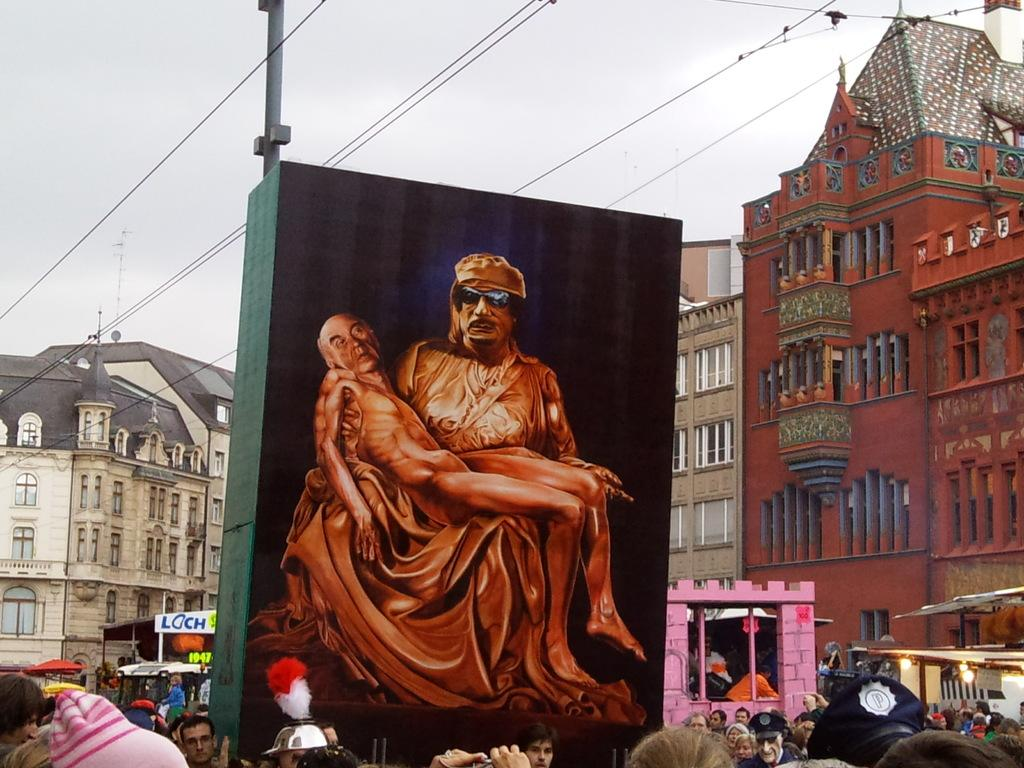How many people can be seen in the image? There are people in the image, but the exact number is not specified. What is depicted on the board in the image? There is a board with an image of two persons in the image. What type of structures are visible in the image? There are buildings with windows in the image. What can be seen illuminating the scene in the image? There are lights visible in the image. What type of infrastructure is present in the image? Wires and a pole are present in the image. What is visible in the background of the image? The sky is visible in the background of the image. What type of reaction can be seen from the worm in the image? There is no worm present in the image, so it is not possible to observe any reaction from a worm. 